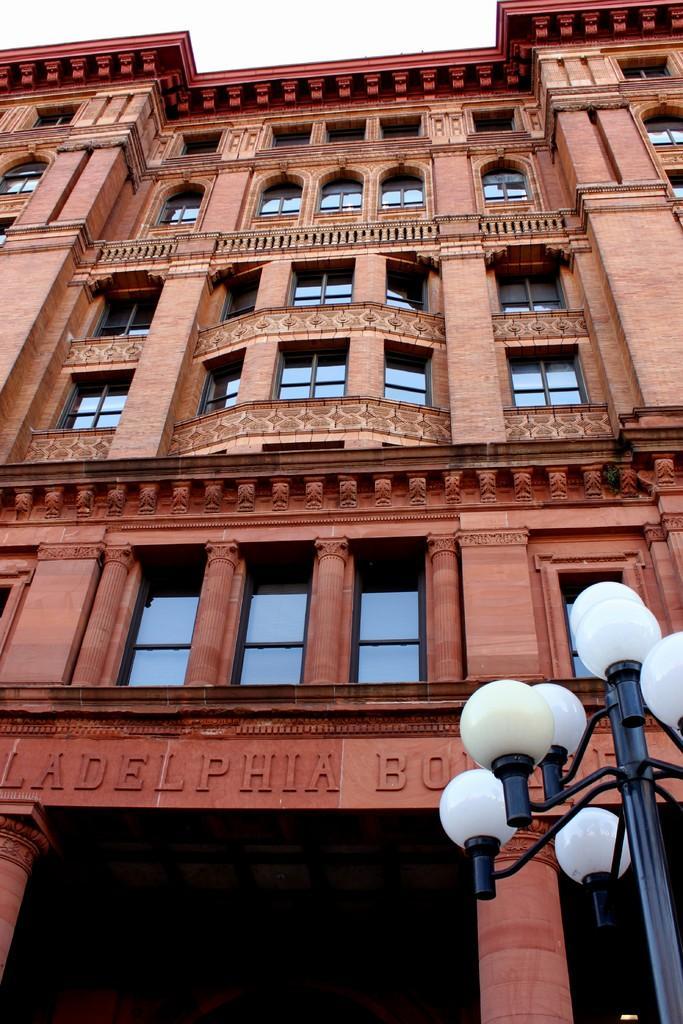Could you give a brief overview of what you see in this image? There is a building with glass windows. On the building something is written. On the right side there is a pole with lights. 